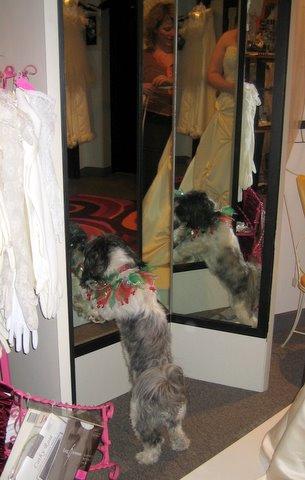Is there a mirror in the room?
Quick response, please. Yes. What type of dress is the lady trying on?
Answer briefly. Wedding. What is the dog doing?
Answer briefly. Looking in mirror. 